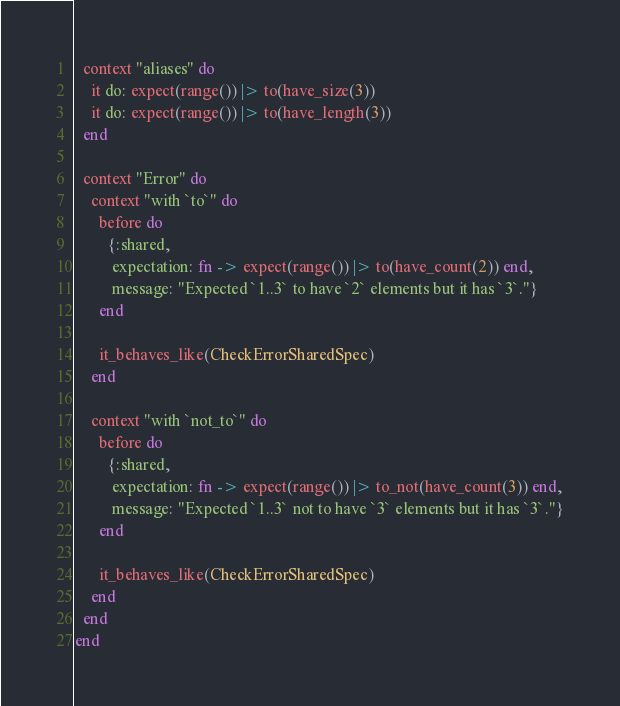<code> <loc_0><loc_0><loc_500><loc_500><_Elixir_>
  context "aliases" do
    it do: expect(range()) |> to(have_size(3))
    it do: expect(range()) |> to(have_length(3))
  end

  context "Error" do
    context "with `to`" do
      before do
        {:shared,
         expectation: fn -> expect(range()) |> to(have_count(2)) end,
         message: "Expected `1..3` to have `2` elements but it has `3`."}
      end

      it_behaves_like(CheckErrorSharedSpec)
    end

    context "with `not_to`" do
      before do
        {:shared,
         expectation: fn -> expect(range()) |> to_not(have_count(3)) end,
         message: "Expected `1..3` not to have `3` elements but it has `3`."}
      end

      it_behaves_like(CheckErrorSharedSpec)
    end
  end
end
</code> 